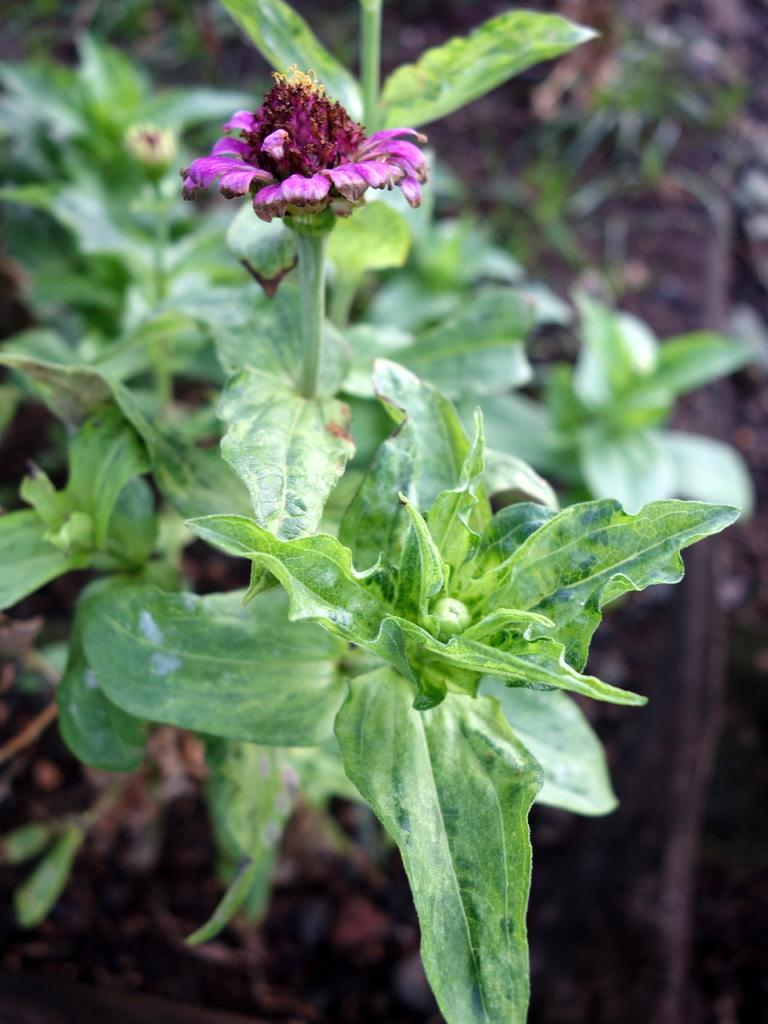What type of plant is featured in the picture? There is a plant with a flower in the picture. Can you describe the background of the image? The background of the image is blurred. How many pies are displayed on the plant in the image? There are no pies present in the image; it features a plant with a flower. What type of nut can be seen growing on the plant in the image? There are no nuts visible on the plant in the image; it has a flower. 